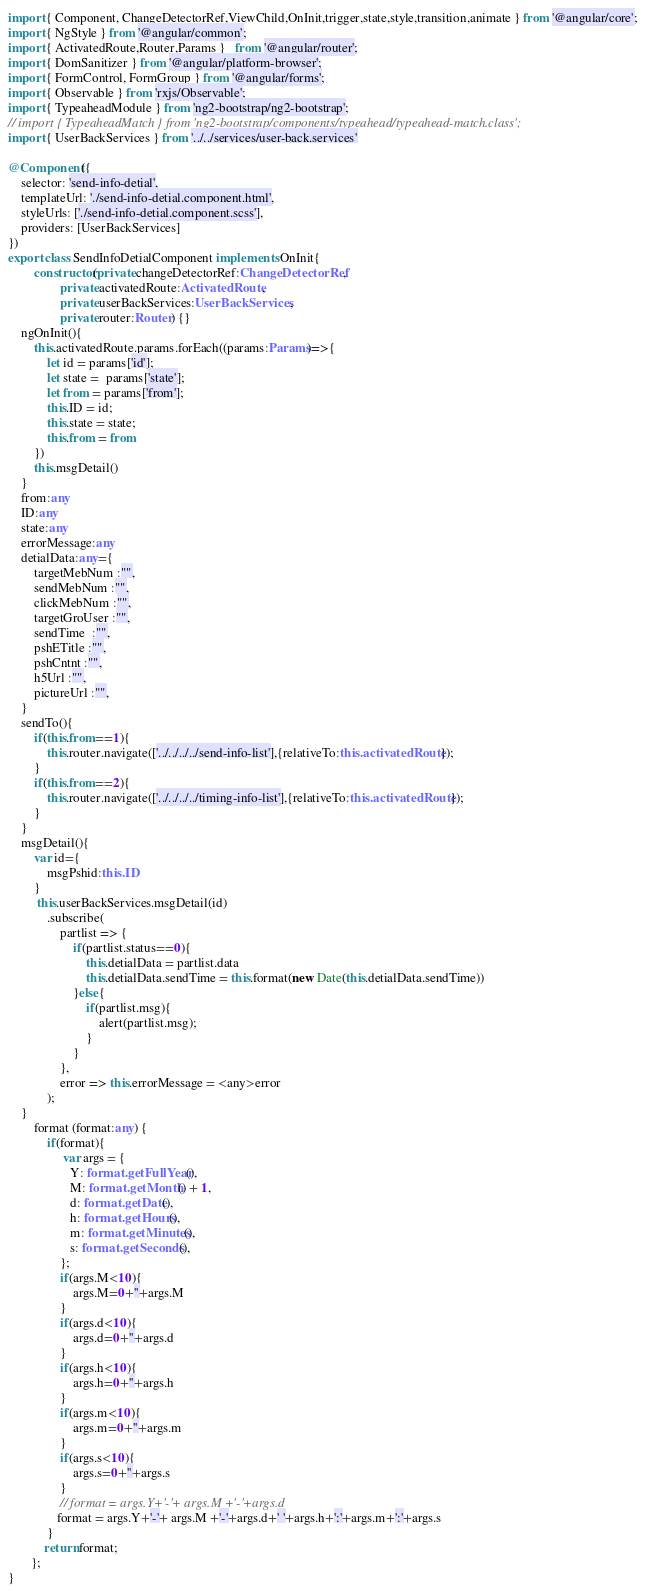<code> <loc_0><loc_0><loc_500><loc_500><_TypeScript_>import { Component, ChangeDetectorRef,ViewChild,OnInit,trigger,state,style,transition,animate } from '@angular/core';
import { NgStyle } from '@angular/common';
import { ActivatedRoute,Router,Params }   from '@angular/router';
import { DomSanitizer } from '@angular/platform-browser';
import { FormControl, FormGroup } from '@angular/forms';
import { Observable } from 'rxjs/Observable';
import { TypeaheadModule } from 'ng2-bootstrap/ng2-bootstrap';
// import { TypeaheadMatch } from 'ng2-bootstrap/components/typeahead/typeahead-match.class';
import { UserBackServices } from '../../services/user-back.services'

@Component({
	selector: 'send-info-detial',
	templateUrl: './send-info-detial.component.html',
	styleUrls: ['./send-info-detial.component.scss'],
	providers: [UserBackServices]
})
export class SendInfoDetialComponent implements OnInit{
		constructor(private changeDetectorRef:ChangeDetectorRef,
				private activatedRoute:ActivatedRoute,
				private userBackServices:UserBackServices,
        		private router:Router) {}
	ngOnInit(){
		this.activatedRoute.params.forEach((params:Params)=>{
			let id = params['id'];
			let state =  params['state'];
			let from = params['from'];
			this.ID = id;
			this.state = state;
			this.from = from
		})
		this.msgDetail()
	}
	from:any
	ID:any
	state:any
	errorMessage:any
	detialData:any={
		targetMebNum :"",
		sendMebNum :"",
		clickMebNum :"",
		targetGroUser :"",
		sendTime  :"",
		pshETitle :"",
		pshCntnt :"",
		h5Url :"",
		pictureUrl :"",
	}
	sendTo(){
		if(this.from==1){
			this.router.navigate(['../../../../send-info-list'],{relativeTo:this.activatedRoute}); 
		}
		if(this.from==2){
			this.router.navigate(['../../../../timing-info-list'],{relativeTo:this.activatedRoute}); 
		}
	}
	msgDetail(){
		var id={
			msgPshid:this.ID
		}
		 this.userBackServices.msgDetail(id) 
	        .subscribe(
	            partlist => {   
	                if(partlist.status==0){
	    				this.detialData = partlist.data
	    				this.detialData.sendTime = this.format(new Date(this.detialData.sendTime))  
					}else{
						if(partlist.msg){
							alert(partlist.msg);
						}
	                }
	            },  
	            error => this.errorMessage = <any>error
		    ); 
	}
		format (format:any) {
			if(format){
				 var args = {
	           	   Y: format.getFullYear(),
	               M: format.getMonth() + 1,
	               d: format.getDate(),
	               h: format.getHours(),
	               m: format.getMinutes(),
	               s: format.getSeconds(),
	           	};
	           	if(args.M<10){
	           		args.M=0+''+args.M
	           	}
	           	if(args.d<10){
	           		args.d=0+''+args.d
	           	}
	           	if(args.h<10){
	           		args.h=0+''+args.h
	           	}
	           	if(args.m<10){
	           		args.m=0+''+args.m
	           	}
	           	if(args.s<10){
	           		args.s=0+''+args.s
	           	}
	           	// format = args.Y+'-'+ args.M +'-'+args.d
	           format = args.Y+'-'+ args.M +'-'+args.d+' '+args.h+':'+args.m+':'+args.s
			}
           return format;
       };
}</code> 